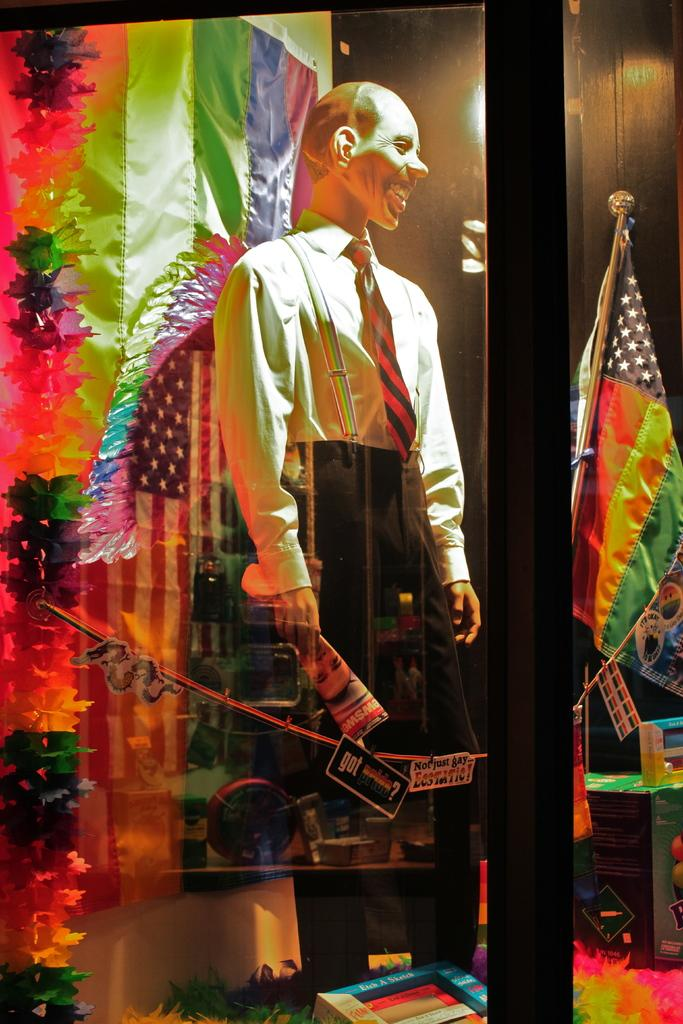What is visible through the glass in the image? A mannequin wearing a dress is visible through the glass. What else can be seen in the image besides the glass? There is a flag and a light in the image. Are there any colorful objects in the image? Yes, there are colorful objects in the image. How does the property adjust to the changing wind conditions in the image? There is no property or wind mentioned in the image; it only features a glass, a mannequin, a flag, a light, and colorful objects. 